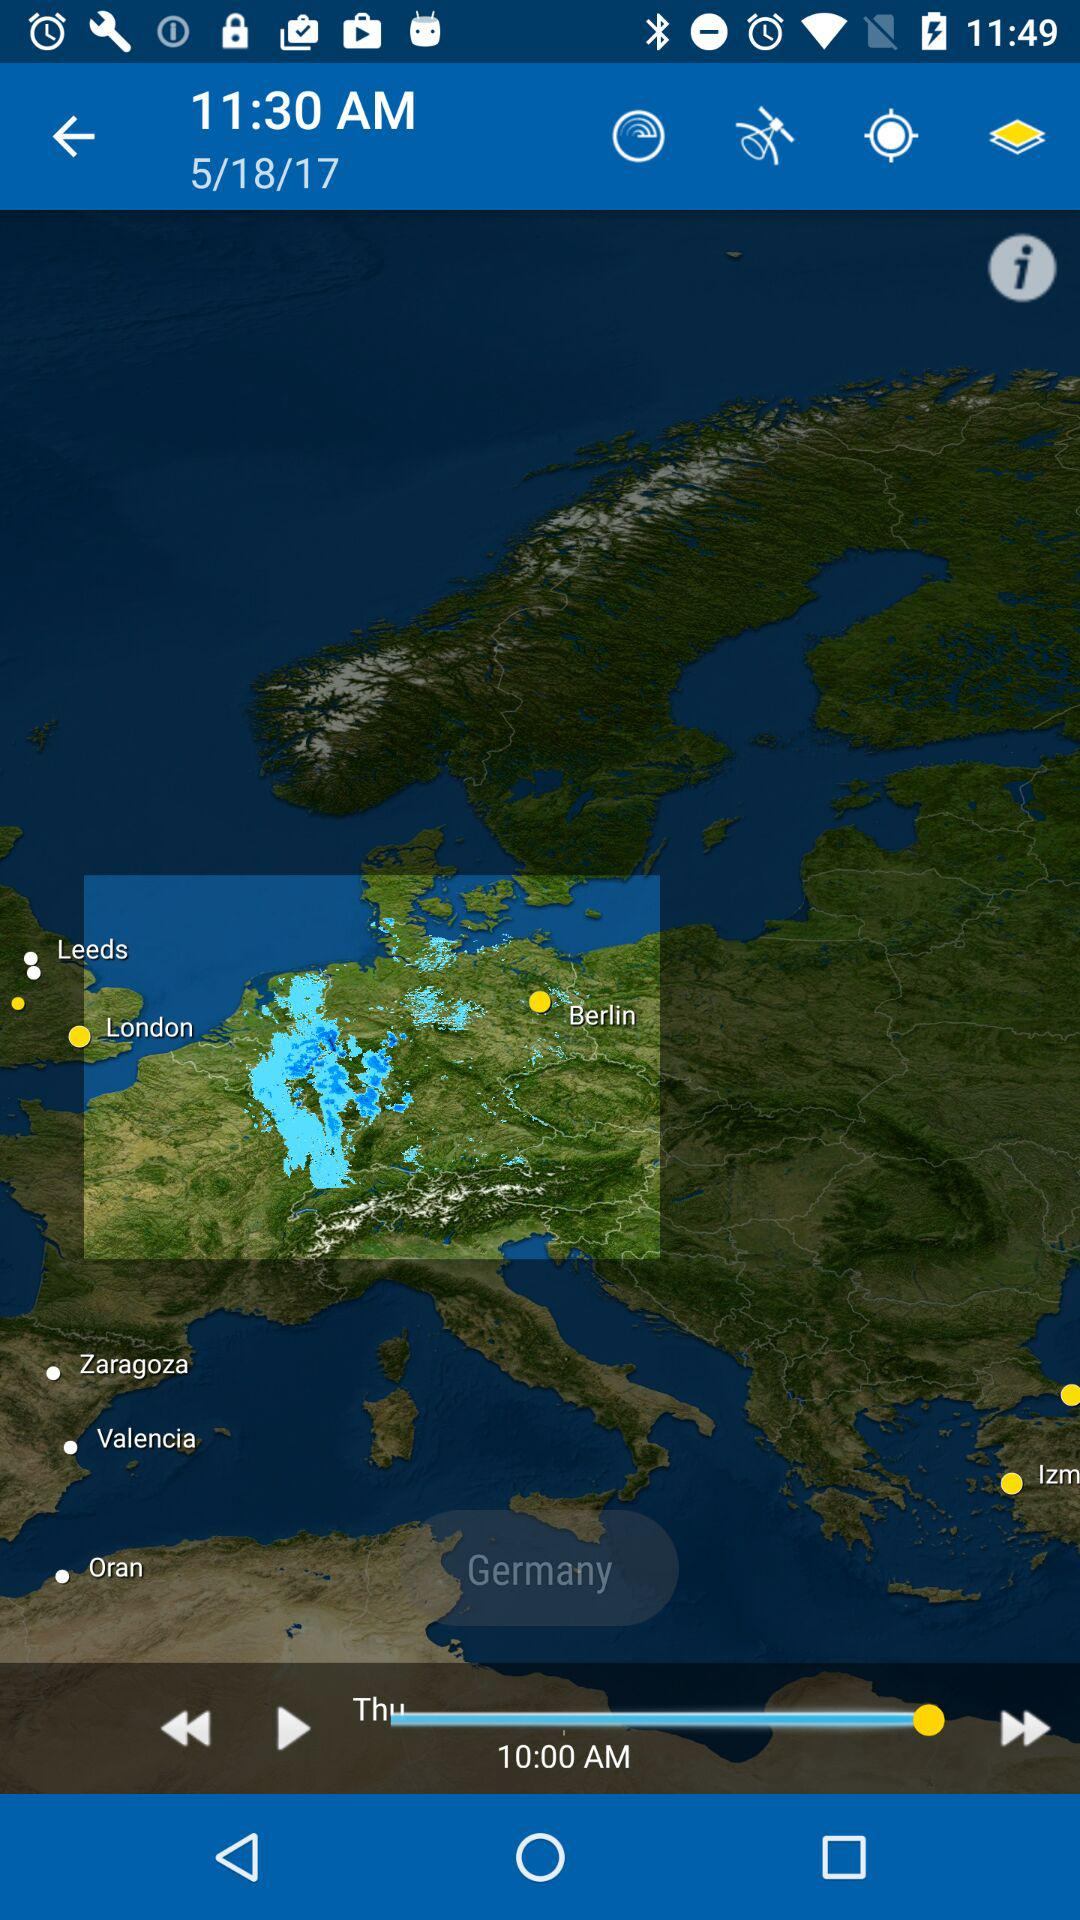What is the date? The date is 5/18/17. 